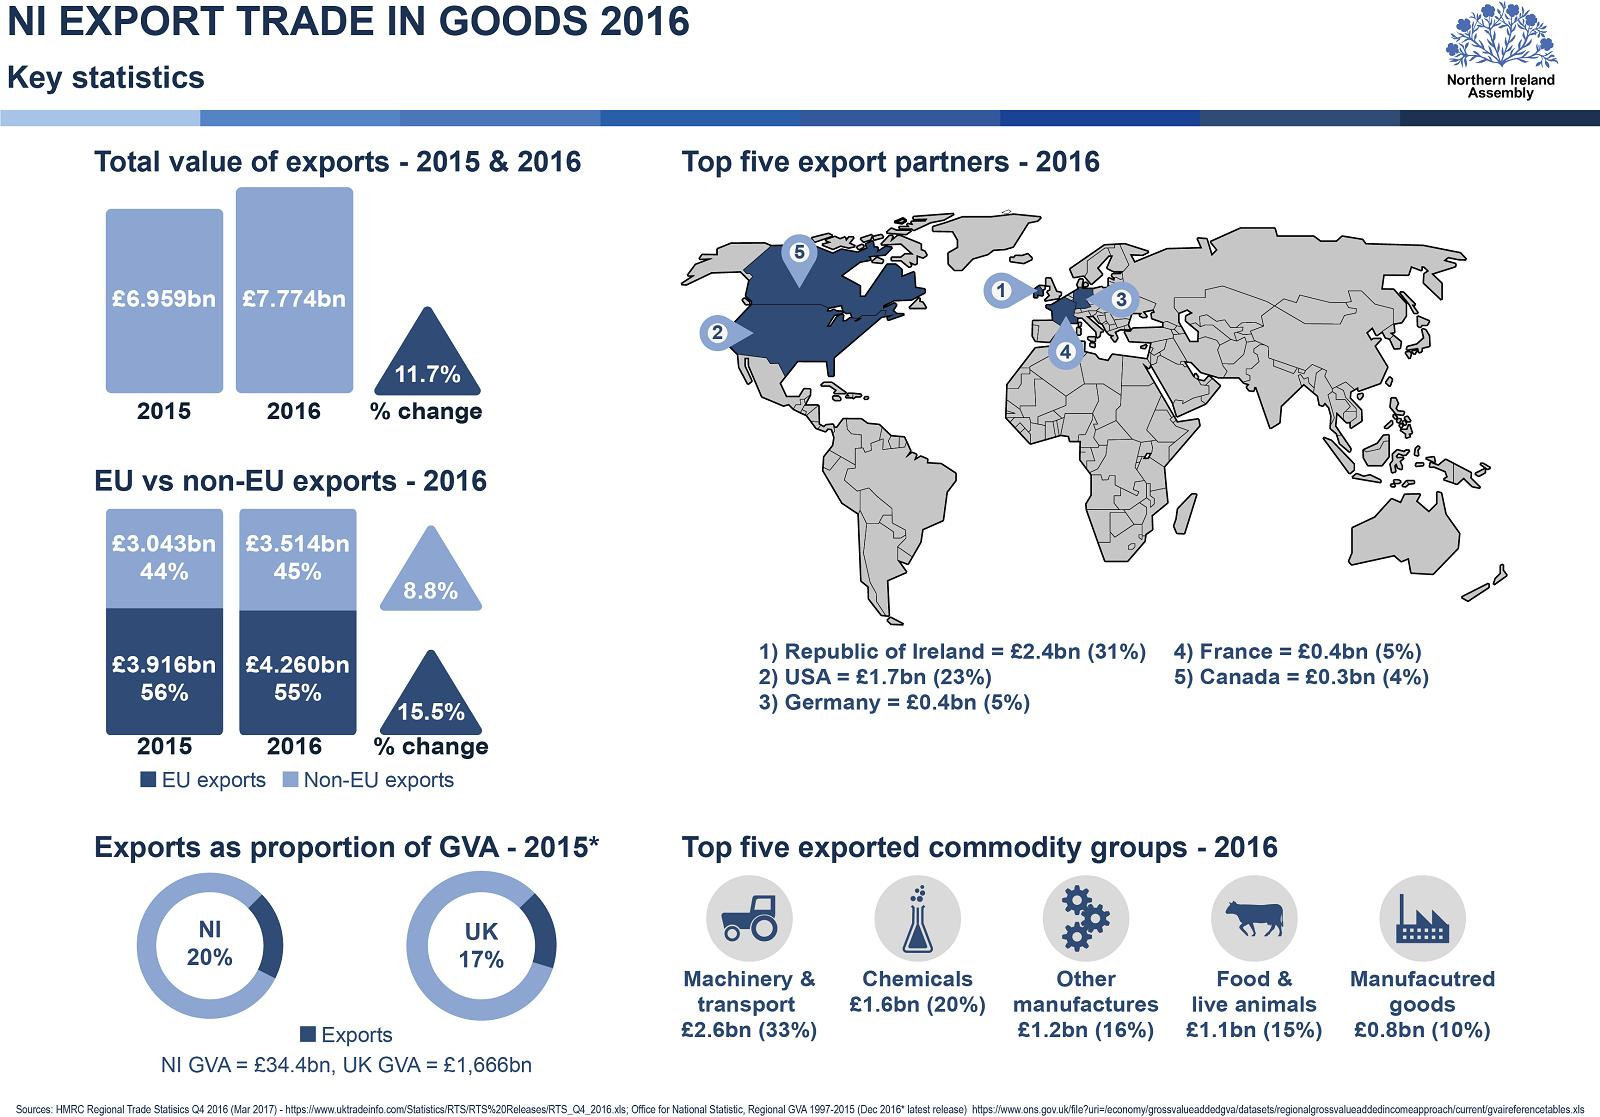Outline some significant characteristics in this image. Out of the export partners identified on the map, three are located in Europe. In 2016, the second most exported commodity group was chemicals. In 2015, the export volume of the European Union (EU) was higher than that of non-EU countries. The percentage of manufactured goods exported was approximately 10%. 